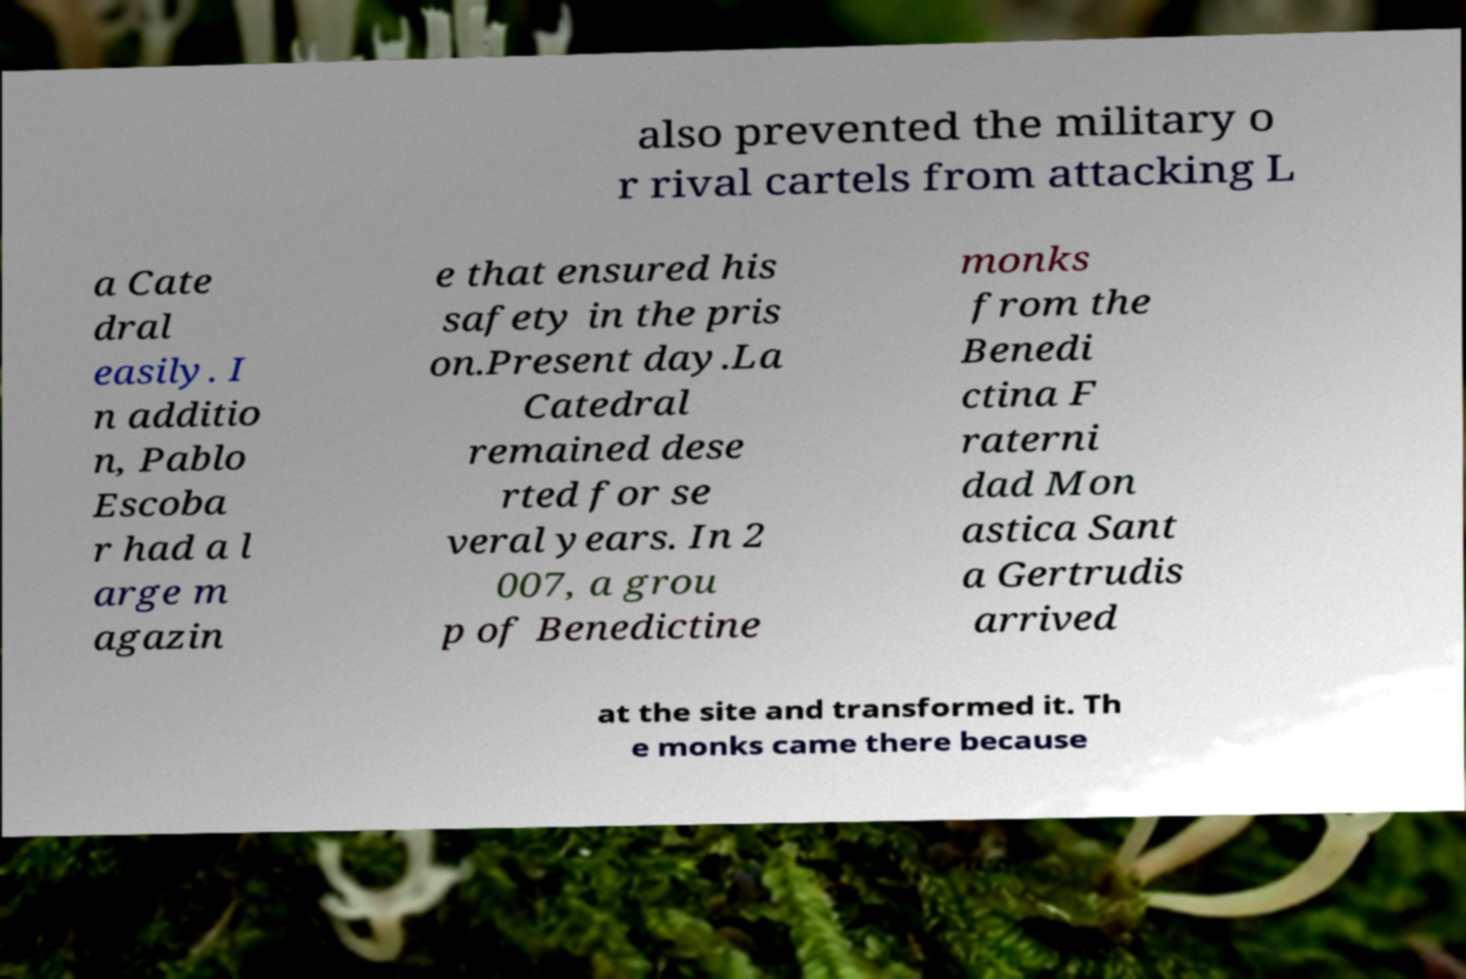Could you extract and type out the text from this image? also prevented the military o r rival cartels from attacking L a Cate dral easily. I n additio n, Pablo Escoba r had a l arge m agazin e that ensured his safety in the pris on.Present day.La Catedral remained dese rted for se veral years. In 2 007, a grou p of Benedictine monks from the Benedi ctina F raterni dad Mon astica Sant a Gertrudis arrived at the site and transformed it. Th e monks came there because 